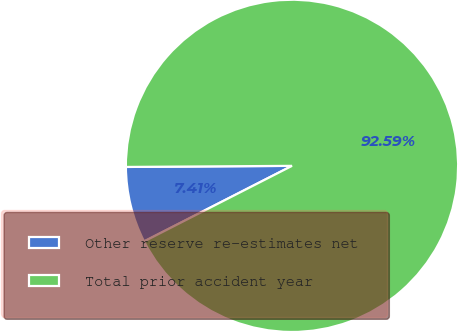Convert chart. <chart><loc_0><loc_0><loc_500><loc_500><pie_chart><fcel>Other reserve re-estimates net<fcel>Total prior accident year<nl><fcel>7.41%<fcel>92.59%<nl></chart> 